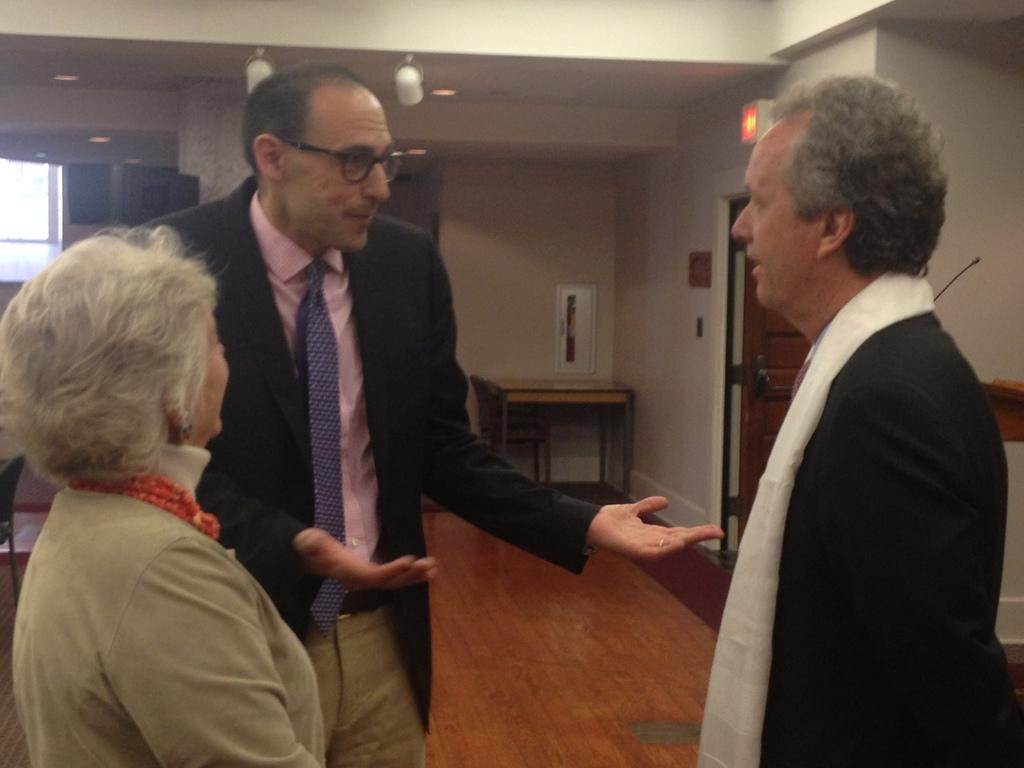How many people are present in the image? There are three persons standing in the image. Can you describe the scene in the image? There are three persons standing, and there are other objects in the background of the image. What type of game is being played by the persons in the image? There is no game being played in the image; it only shows three persons standing. Can you describe the tail of the animal in the image? There is no animal with a tail present in the image; it only shows three persons standing and objects in the background. 